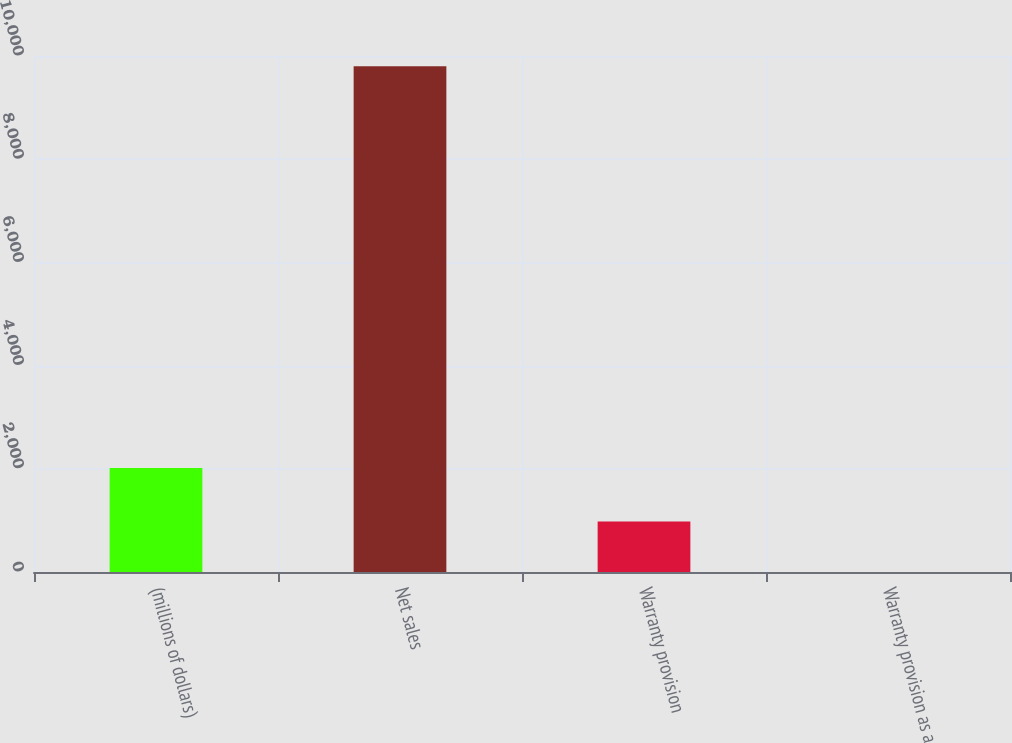<chart> <loc_0><loc_0><loc_500><loc_500><bar_chart><fcel>(millions of dollars)<fcel>Net sales<fcel>Warranty provision<fcel>Warranty provision as a<nl><fcel>2017<fcel>9799.3<fcel>980.56<fcel>0.7<nl></chart> 